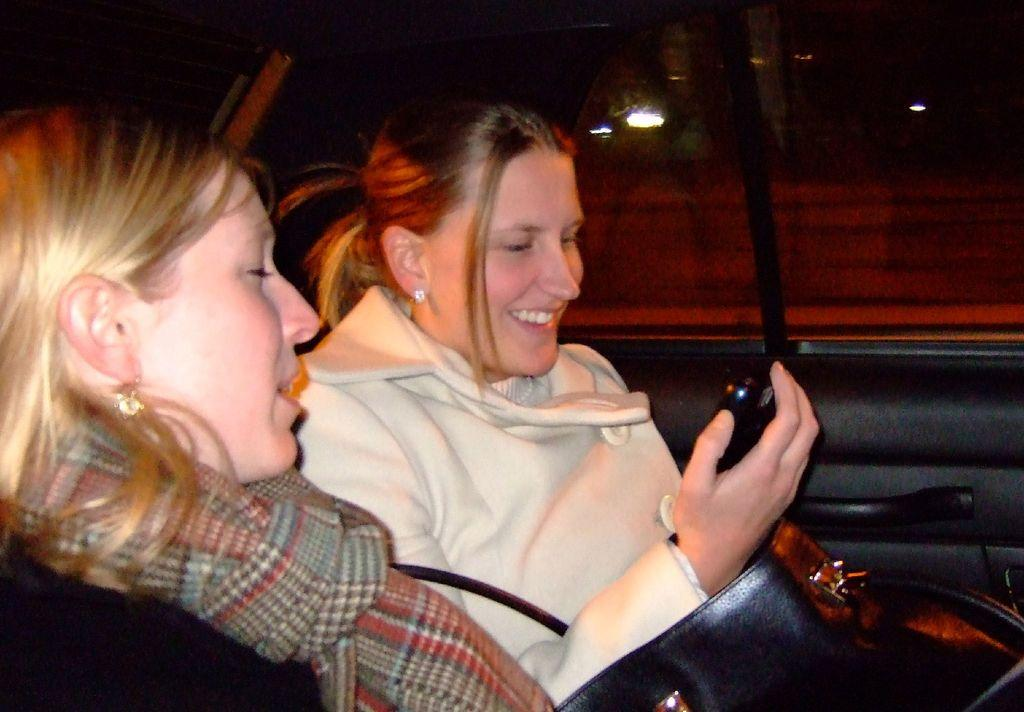How many women are inside the vehicle in the image? There are two women inside the vehicle in the image. What is one of the women holding? One of the women is holding a mobile. What can be seen in the image besides the women and the mobile? There is a bag visible in the image. What can be seen in the background of the image? There are lights and other objects visible in the background of the image. What color is the grape that the woman is eating in the image? There is no grape present in the image, and the woman is not eating anything. 